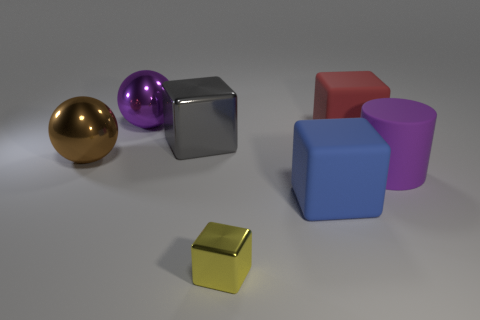Add 1 blocks. How many objects exist? 8 Subtract all balls. How many objects are left? 5 Subtract 0 blue cylinders. How many objects are left? 7 Subtract all large red rubber objects. Subtract all large matte cylinders. How many objects are left? 5 Add 6 purple cylinders. How many purple cylinders are left? 7 Add 5 big purple cylinders. How many big purple cylinders exist? 6 